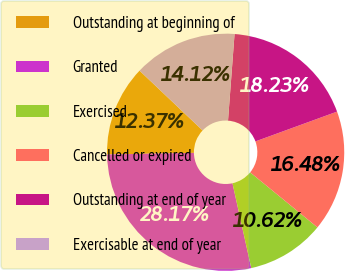Convert chart to OTSL. <chart><loc_0><loc_0><loc_500><loc_500><pie_chart><fcel>Outstanding at beginning of<fcel>Granted<fcel>Exercised<fcel>Cancelled or expired<fcel>Outstanding at end of year<fcel>Exercisable at end of year<nl><fcel>12.37%<fcel>28.17%<fcel>10.62%<fcel>16.48%<fcel>18.23%<fcel>14.12%<nl></chart> 